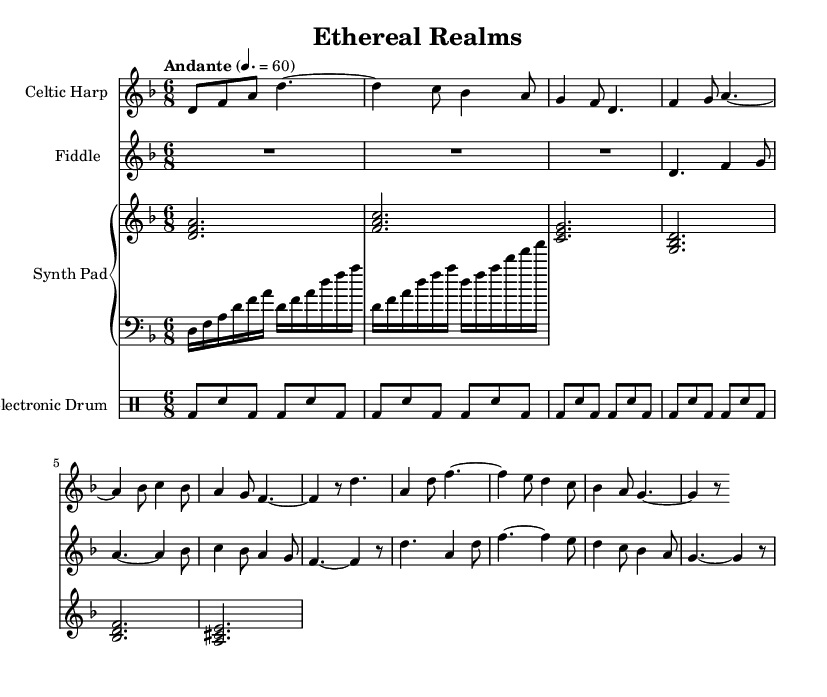What is the key signature of this music? The key signature is D minor, indicated by one flat (B flat) at the beginning of the staff.
Answer: D minor What is the time signature of this music? The time signature is 6/8, which is shown at the beginning of the score. This indicates there are six eighth-note beats in each measure.
Answer: 6/8 What is the tempo marking of this music? The tempo marking is "Andante," which usually indicates a moderate walking pace, and this specific marking of "4. = 60" gives a metronome marking suggesting a speed of 60 beats per minute.
Answer: Andante How many staves are used in this score? The score contains four staves: one for the Celtic Harp, one for the Fiddle, a Piano Staff with two staves for the Synth Pad and Harp Arpeggio, and one for the Electronic Drum.
Answer: Four Which electronic element is used in this composition? The electronic element used here is the Synth Pad, which adds a modern texture to the traditional sounds of the Celtic Harp and Fiddle.
Answer: Synth Pad What instruments are used in this piece? The instruments used include the Celtic Harp, Fiddle, Synth Pad, and Electronic Drum, showcasing a blend of traditional and electronic sounds.
Answer: Celtic Harp, Fiddle, Synth Pad, Electronic Drum What type of rhythm does the electronic drum follow? The electronic drum uses a straightforward rhythmic pattern characterized by bass drum and snare combinations, following a consistent rhythm across the measures.
Answer: Consistent rhythm 